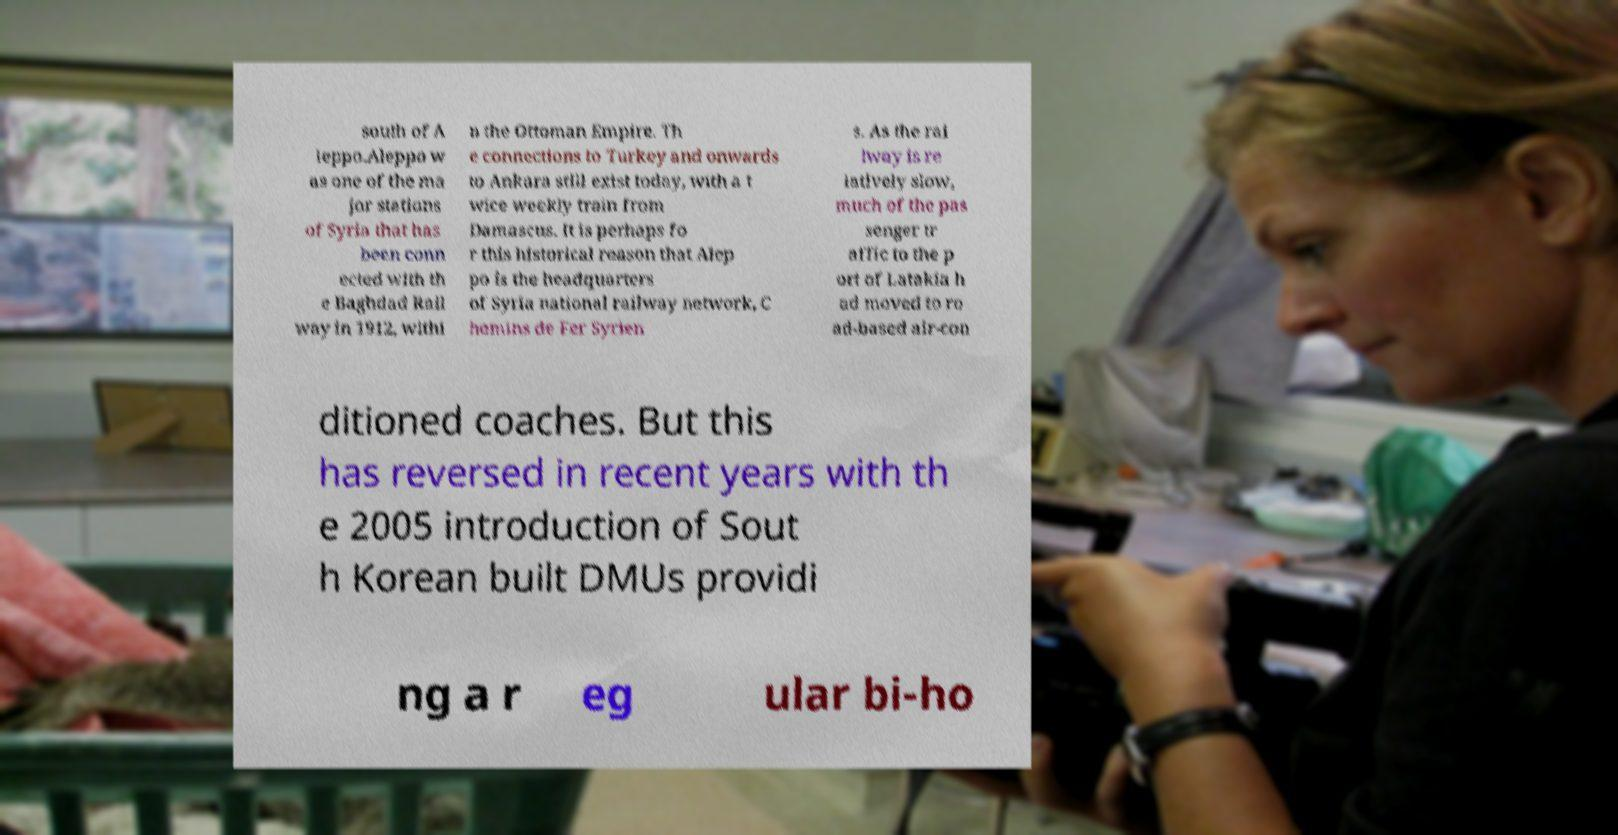For documentation purposes, I need the text within this image transcribed. Could you provide that? south of A leppo.Aleppo w as one of the ma jor stations of Syria that has been conn ected with th e Baghdad Rail way in 1912, withi n the Ottoman Empire. Th e connections to Turkey and onwards to Ankara still exist today, with a t wice weekly train from Damascus. It is perhaps fo r this historical reason that Alep po is the headquarters of Syria national railway network, C hemins de Fer Syrien s. As the rai lway is re latively slow, much of the pas senger tr affic to the p ort of Latakia h ad moved to ro ad-based air-con ditioned coaches. But this has reversed in recent years with th e 2005 introduction of Sout h Korean built DMUs providi ng a r eg ular bi-ho 